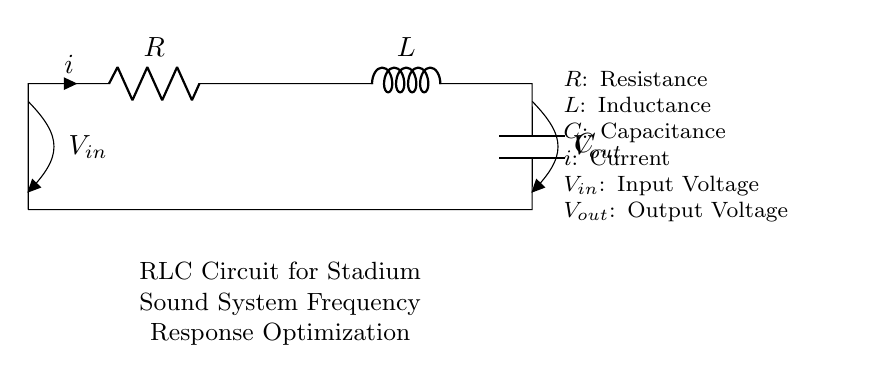What is the resistance in the circuit? The resistance is denoted by the symbol R in the circuit diagram. It is clearly labeled on the resistor component.
Answer: R What is the voltage of the input? The input voltage is indicated by V_{in}, which is shown on the open node at the top of the circuit.
Answer: V_{in} How many components are there in this RLC circuit? The components in this circuit include a resistor, an inductor, and a capacitor, making a total of three components.
Answer: 3 What happens to the current when the capacitor is fully charged? When the capacitor is fully charged, it acts like an open circuit, preventing further current flow. This is understood by recognizing that a fully charged capacitor blocks direct current.
Answer: No current What is the purpose of the inductor in this circuit? The inductor in the circuit is used to store energy in the form of a magnetic field and to resist changes in the current flow. This is significant in optimizing frequency response for audio applications, as it helps manage inductive reactance.
Answer: Store energy At what frequency does resonance occur in an RLC circuit? Resonance occurs at the frequency where the inductive reactance equals the capacitive reactance, maximizing output voltage. This is determined by calculating the resonant frequency using the formula f = 1 / (2π√(LC)).
Answer: f = 1 / (2π√(LC)) 